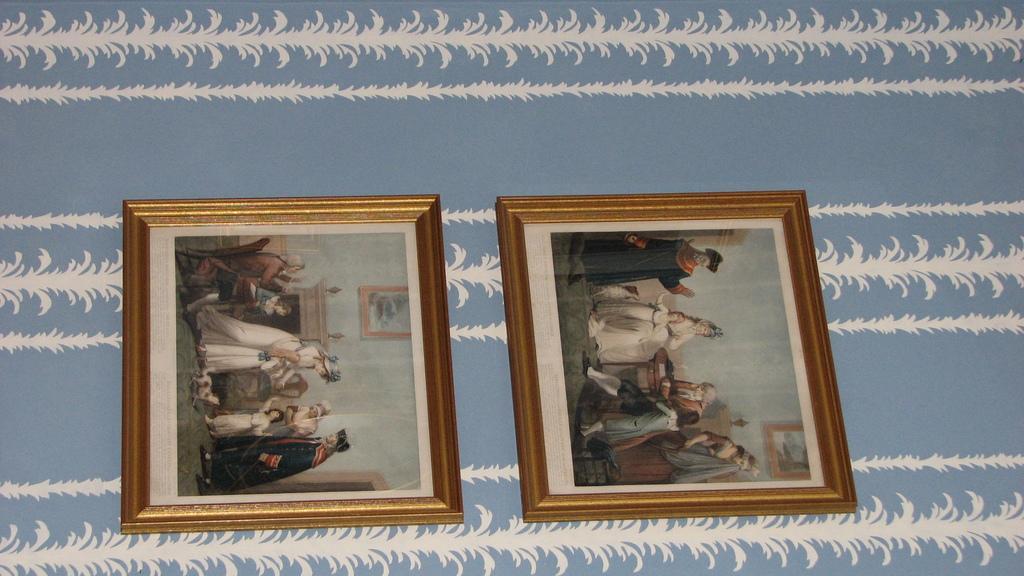Can you describe this image briefly? In this image, we can see two photo frames on the wall. 